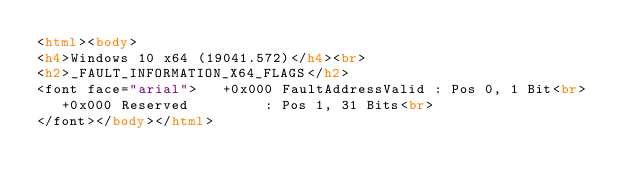<code> <loc_0><loc_0><loc_500><loc_500><_HTML_><html><body>
<h4>Windows 10 x64 (19041.572)</h4><br>
<h2>_FAULT_INFORMATION_X64_FLAGS</h2>
<font face="arial">   +0x000 FaultAddressValid : Pos 0, 1 Bit<br>
   +0x000 Reserved         : Pos 1, 31 Bits<br>
</font></body></html></code> 